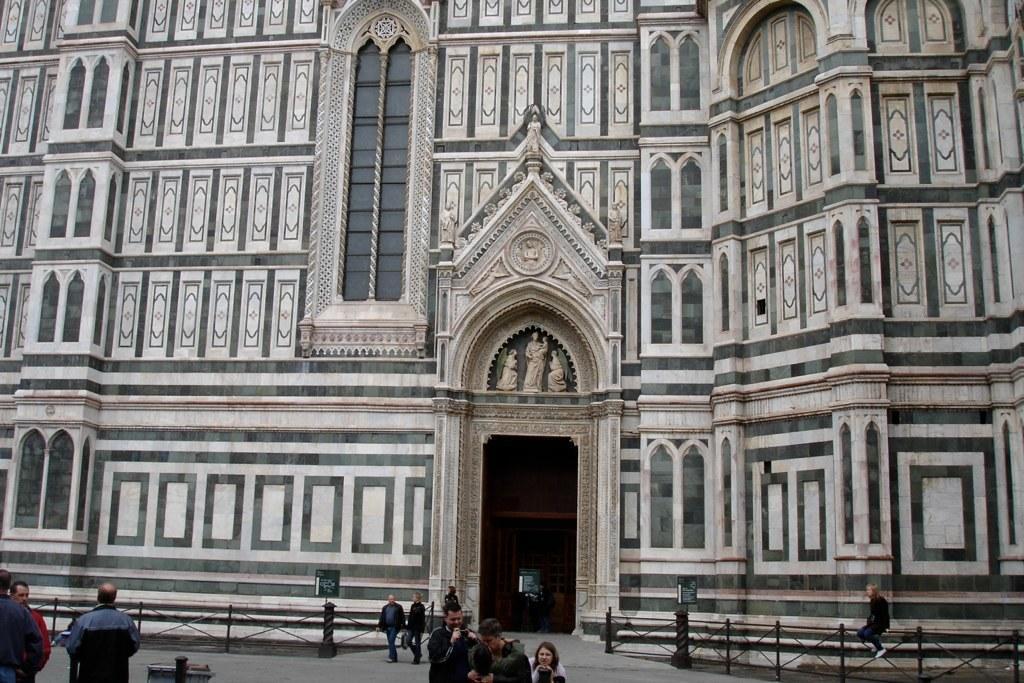How would you summarize this image in a sentence or two? In this picture we can see a building,fence and persons on the ground. 